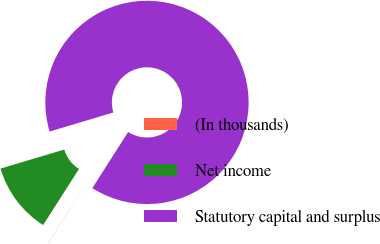<chart> <loc_0><loc_0><loc_500><loc_500><pie_chart><fcel>(In thousands)<fcel>Net income<fcel>Statutory capital and surplus<nl><fcel>0.03%<fcel>11.31%<fcel>88.66%<nl></chart> 